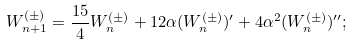Convert formula to latex. <formula><loc_0><loc_0><loc_500><loc_500>W ^ { ( \pm ) } _ { n + 1 } = \frac { 1 5 } { 4 } W ^ { ( \pm ) } _ { n } + 1 2 \alpha ( W ^ { ( \pm ) } _ { n } ) ^ { \prime } + 4 \alpha ^ { 2 } ( W ^ { ( \pm ) } _ { n } ) ^ { \prime \prime } ;</formula> 